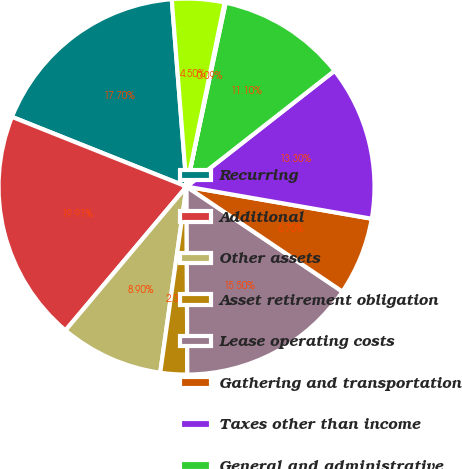Convert chart to OTSL. <chart><loc_0><loc_0><loc_500><loc_500><pie_chart><fcel>Recurring<fcel>Additional<fcel>Other assets<fcel>Asset retirement obligation<fcel>Lease operating costs<fcel>Gathering and transportation<fcel>Taxes other than income<fcel>General and administrative<fcel>Transaction reorganization and<fcel>Financing costs net<nl><fcel>17.7%<fcel>19.91%<fcel>8.9%<fcel>2.3%<fcel>15.5%<fcel>6.7%<fcel>13.3%<fcel>11.1%<fcel>0.09%<fcel>4.5%<nl></chart> 